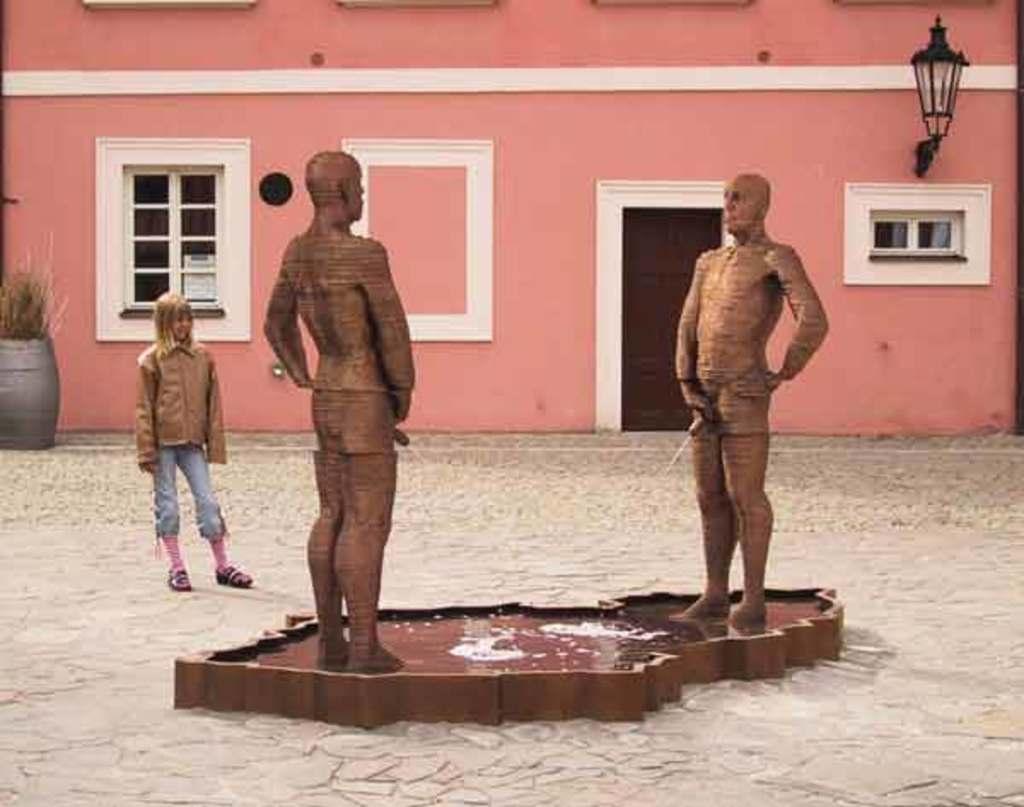In one or two sentences, can you explain what this image depicts? There are two statues on a pond. On that there is water. In the back there is a building with windows, door and light. There is a person standing. On the left corner there is a pot with plant. 